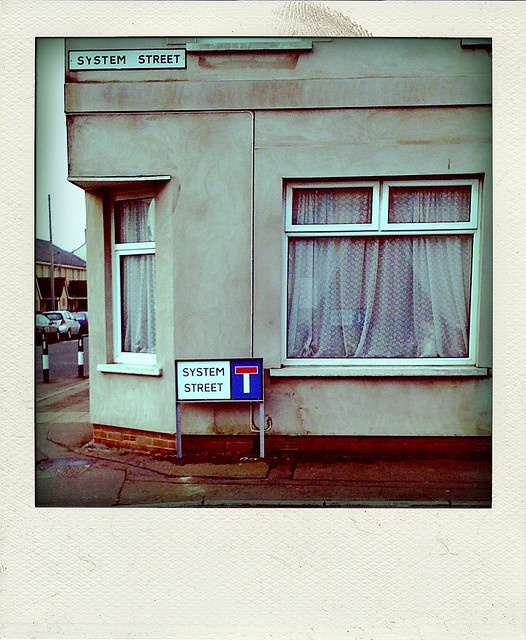Describe the objects in this image and their specific colors. I can see car in lightgray, black, lightblue, darkgray, and gray tones, car in lightgray, black, teal, gray, and darkgray tones, and car in lightgray, black, darkgray, and lightblue tones in this image. 